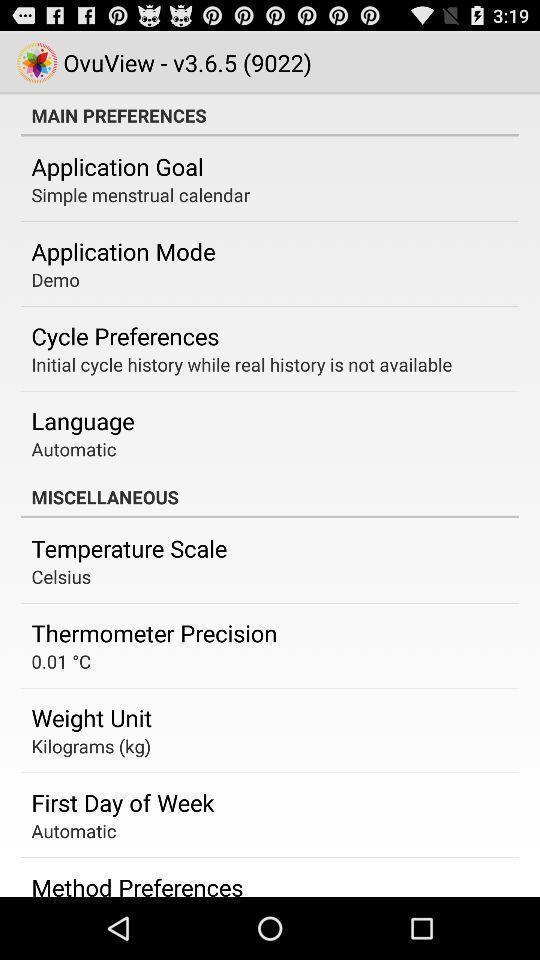Describe the key features of this screenshot. Screen showing main preferences. 